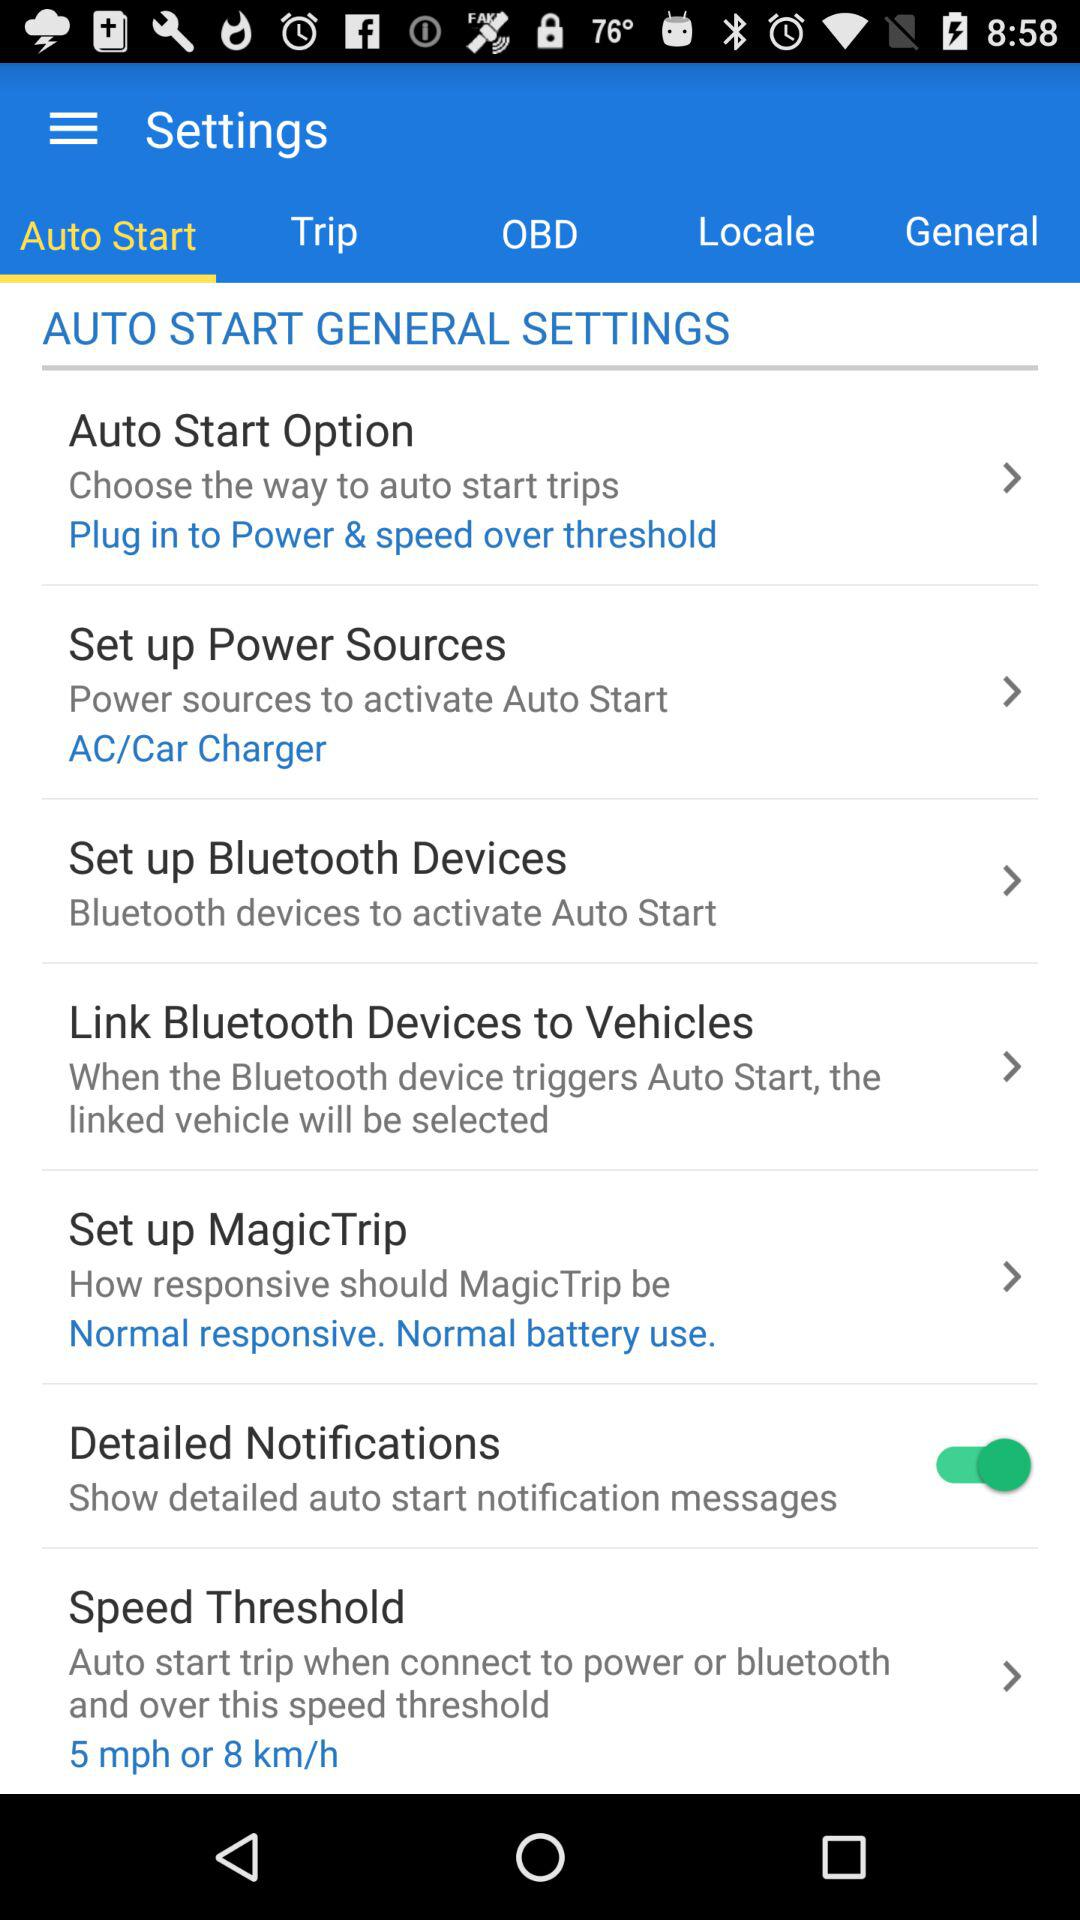Which tab is selected? The selected tab is "Auto Start". 